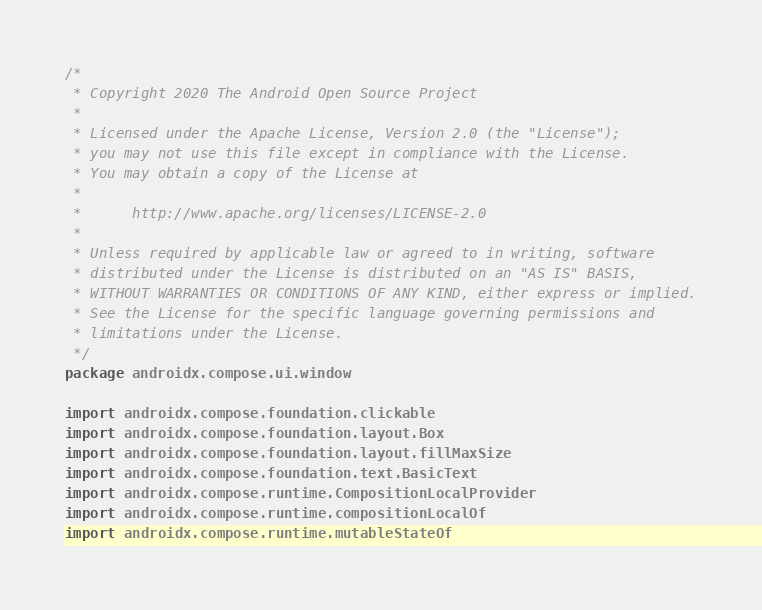Convert code to text. <code><loc_0><loc_0><loc_500><loc_500><_Kotlin_>/*
 * Copyright 2020 The Android Open Source Project
 *
 * Licensed under the Apache License, Version 2.0 (the "License");
 * you may not use this file except in compliance with the License.
 * You may obtain a copy of the License at
 *
 *      http://www.apache.org/licenses/LICENSE-2.0
 *
 * Unless required by applicable law or agreed to in writing, software
 * distributed under the License is distributed on an "AS IS" BASIS,
 * WITHOUT WARRANTIES OR CONDITIONS OF ANY KIND, either express or implied.
 * See the License for the specific language governing permissions and
 * limitations under the License.
 */
package androidx.compose.ui.window

import androidx.compose.foundation.clickable
import androidx.compose.foundation.layout.Box
import androidx.compose.foundation.layout.fillMaxSize
import androidx.compose.foundation.text.BasicText
import androidx.compose.runtime.CompositionLocalProvider
import androidx.compose.runtime.compositionLocalOf
import androidx.compose.runtime.mutableStateOf</code> 